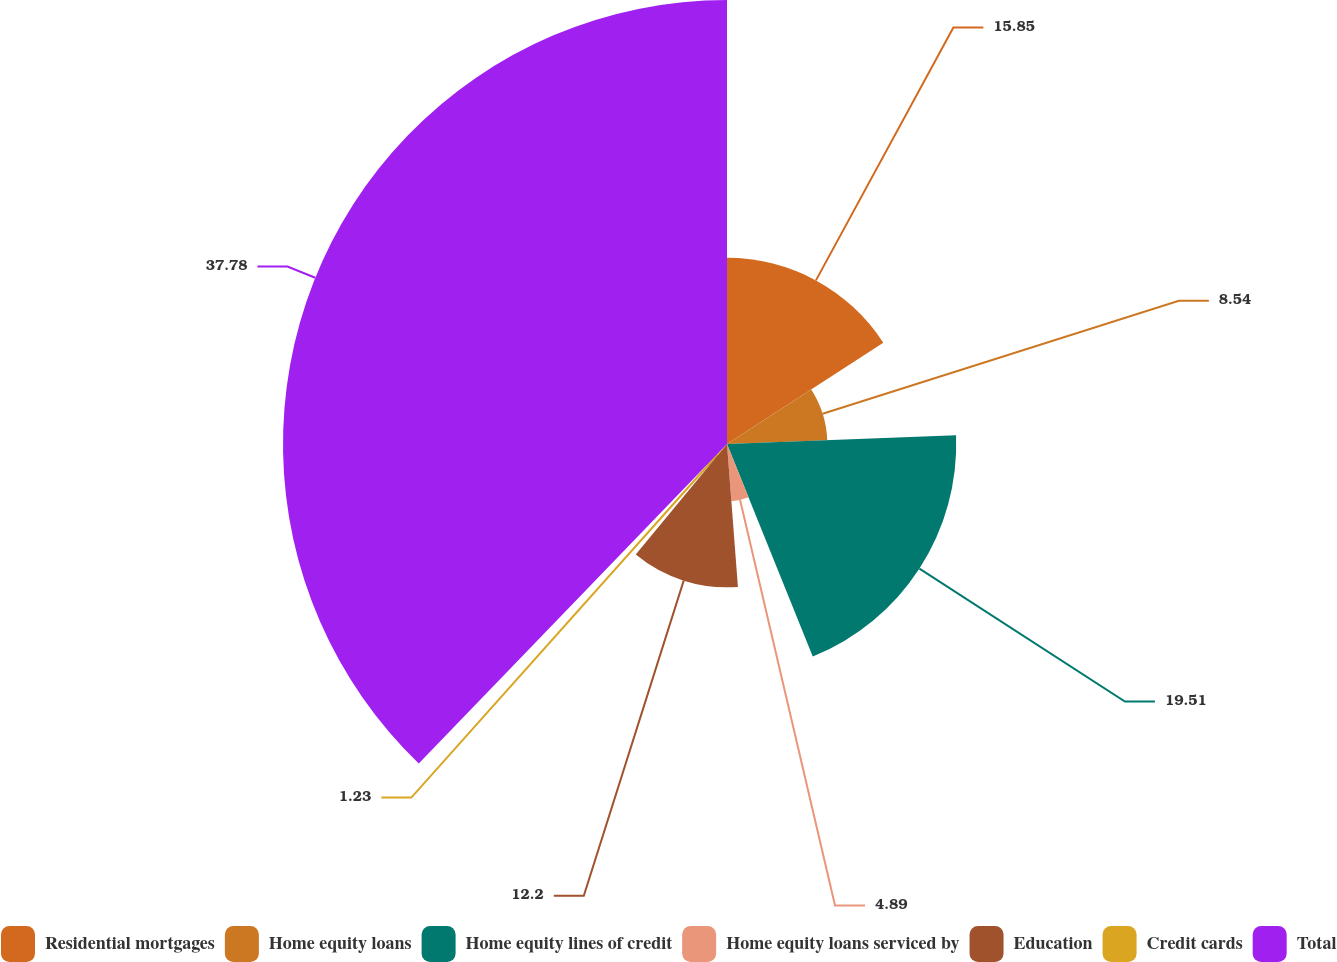<chart> <loc_0><loc_0><loc_500><loc_500><pie_chart><fcel>Residential mortgages<fcel>Home equity loans<fcel>Home equity lines of credit<fcel>Home equity loans serviced by<fcel>Education<fcel>Credit cards<fcel>Total<nl><fcel>15.85%<fcel>8.54%<fcel>19.51%<fcel>4.89%<fcel>12.2%<fcel>1.23%<fcel>37.79%<nl></chart> 